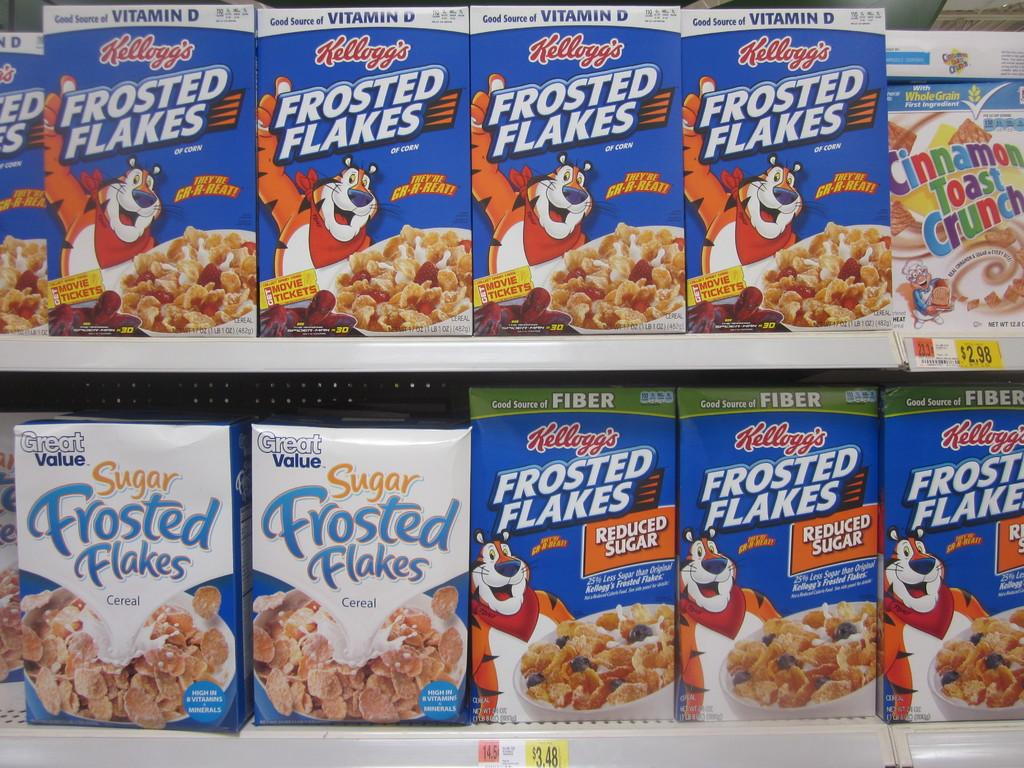What objects are present in the image? There are boxes in the image. What can be seen on the boxes? The boxes have text and images on them. Where are the boxes located in the image? The boxes are in the front of the image. What type of boundary is depicted in the image? There is no boundary depicted in the image; it features boxes with text and images. What kind of test is being conducted in the image? There is no test being conducted in the image; it features boxes with text and images. 